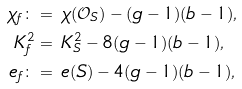Convert formula to latex. <formula><loc_0><loc_0><loc_500><loc_500>\chi _ { f } \colon = & \ \chi ( \mathcal { O } _ { S } ) - ( g - 1 ) ( b - 1 ) , \\ K _ { f } ^ { 2 } = & \ K _ { S } ^ { 2 } - 8 ( g - 1 ) ( b - 1 ) , \\ e _ { f } \colon = & \ e ( S ) - 4 ( g - 1 ) ( b - 1 ) ,</formula> 